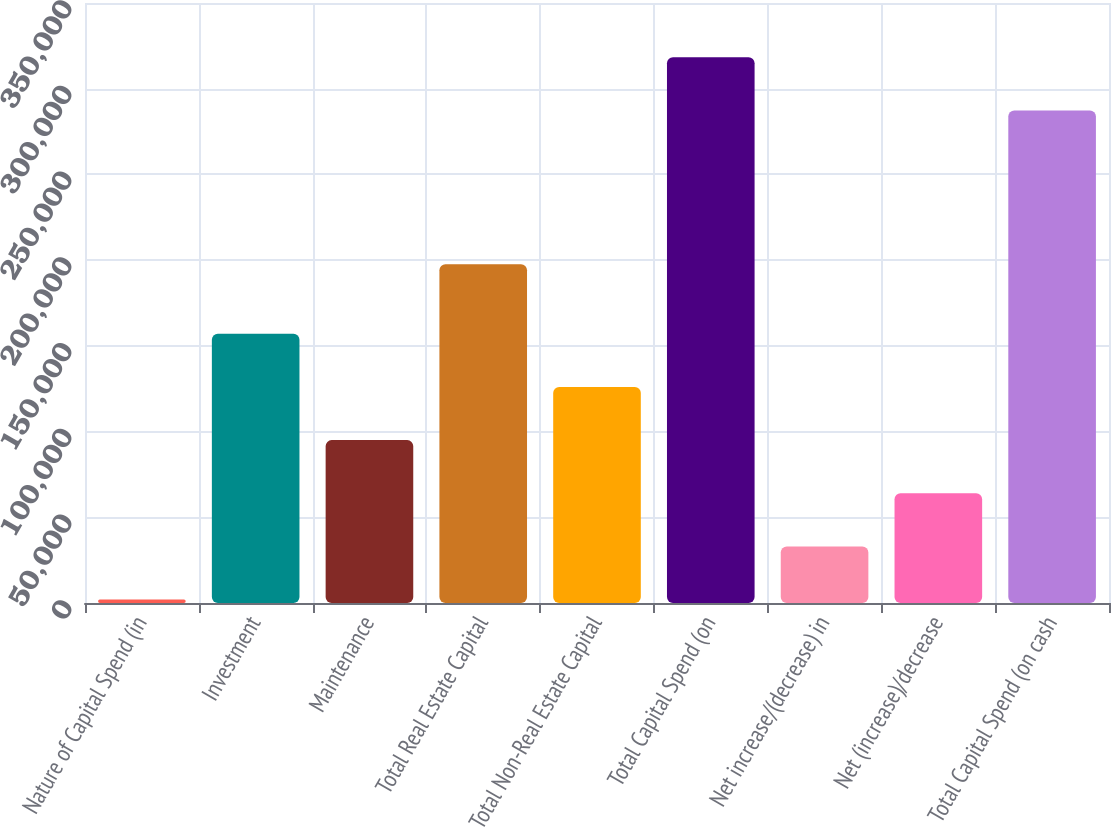Convert chart to OTSL. <chart><loc_0><loc_0><loc_500><loc_500><bar_chart><fcel>Nature of Capital Spend (in<fcel>Investment<fcel>Maintenance<fcel>Total Real Estate Capital<fcel>Total Non-Real Estate Capital<fcel>Total Capital Spend (on<fcel>Net increase/(decrease) in<fcel>Net (increase)/decrease<fcel>Total Capital Spend (on cash<nl><fcel>2013<fcel>157010<fcel>95011.2<fcel>197571<fcel>126011<fcel>318294<fcel>33012.4<fcel>64011.8<fcel>287295<nl></chart> 